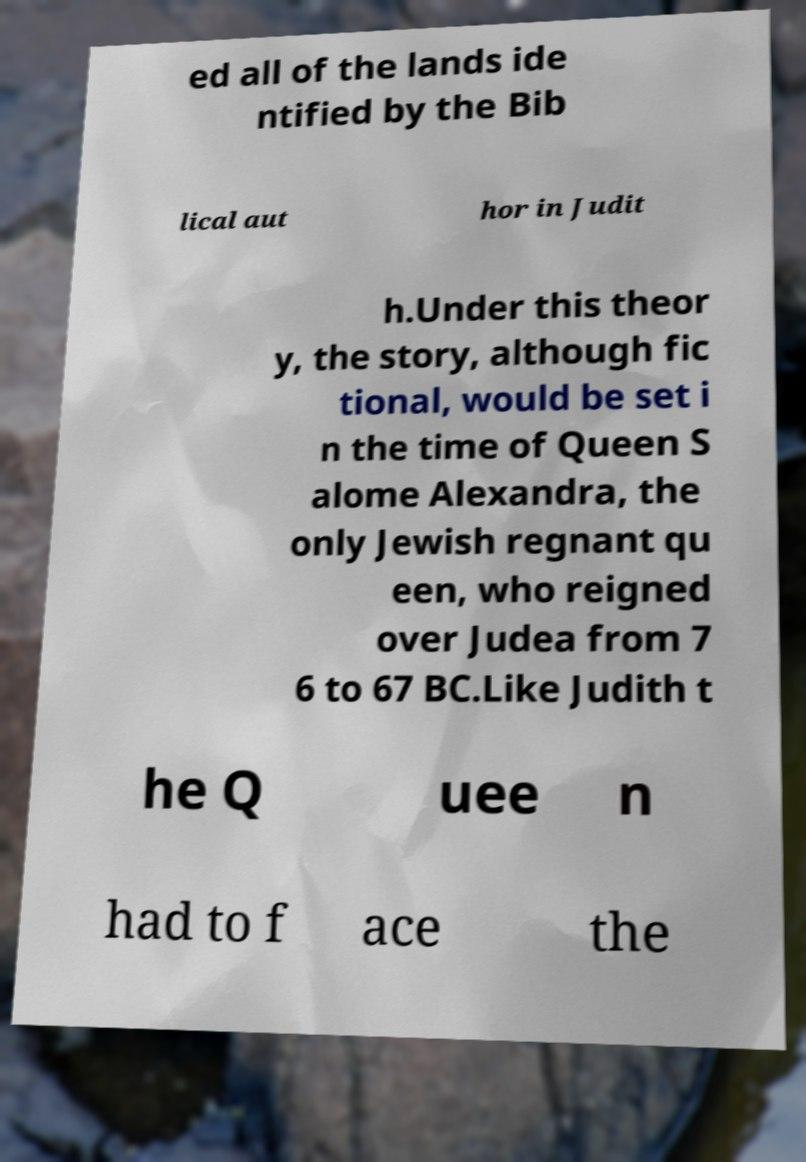I need the written content from this picture converted into text. Can you do that? ed all of the lands ide ntified by the Bib lical aut hor in Judit h.Under this theor y, the story, although fic tional, would be set i n the time of Queen S alome Alexandra, the only Jewish regnant qu een, who reigned over Judea from 7 6 to 67 BC.Like Judith t he Q uee n had to f ace the 